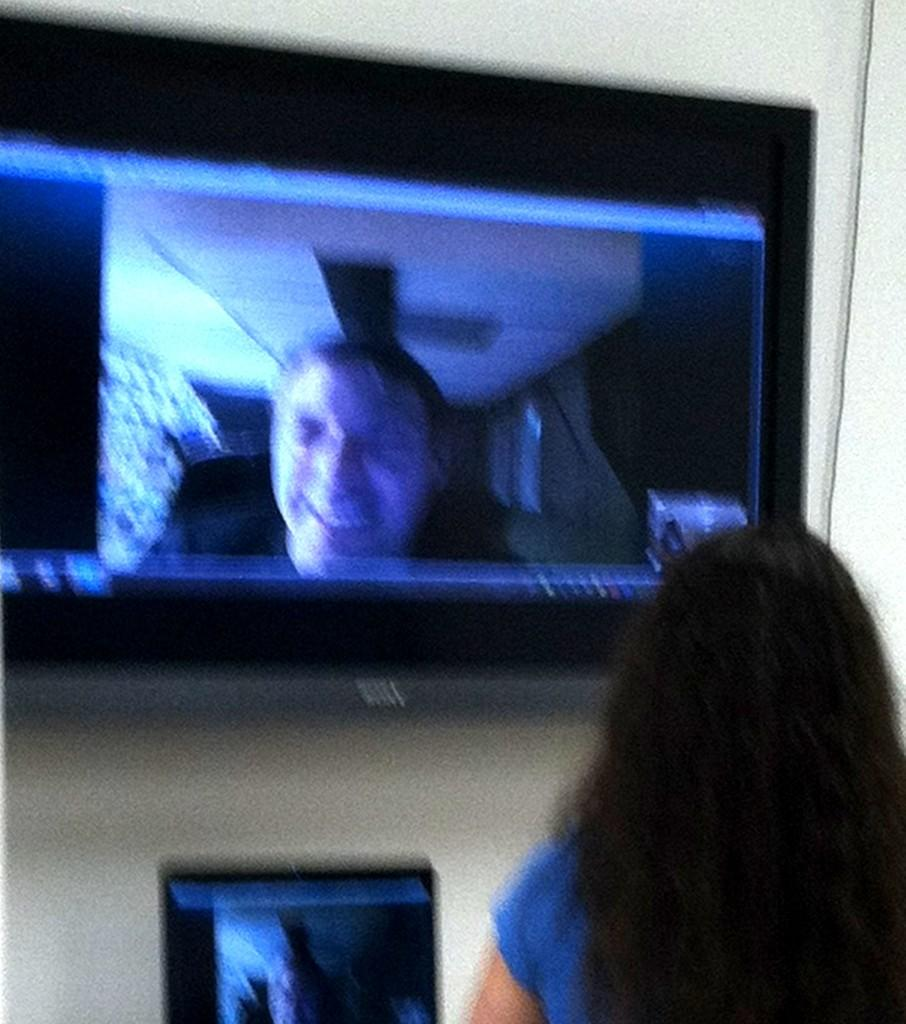Who is present on the right side of the image? There is a lady on the right side of the image. What can be seen in the background of the image? There is a wall in the background of the image. What is attached to the wall? A television is mounted on the wall. Is there any other screen visible in the image? Yes, there is another screen below the television. What type of education can be seen on the lady's stamp in the image? There is no stamp present in the image, and therefore no education can be seen on it. How many tomatoes are visible on the lady's plate in the image? There is no plate or tomatoes present in the image. 